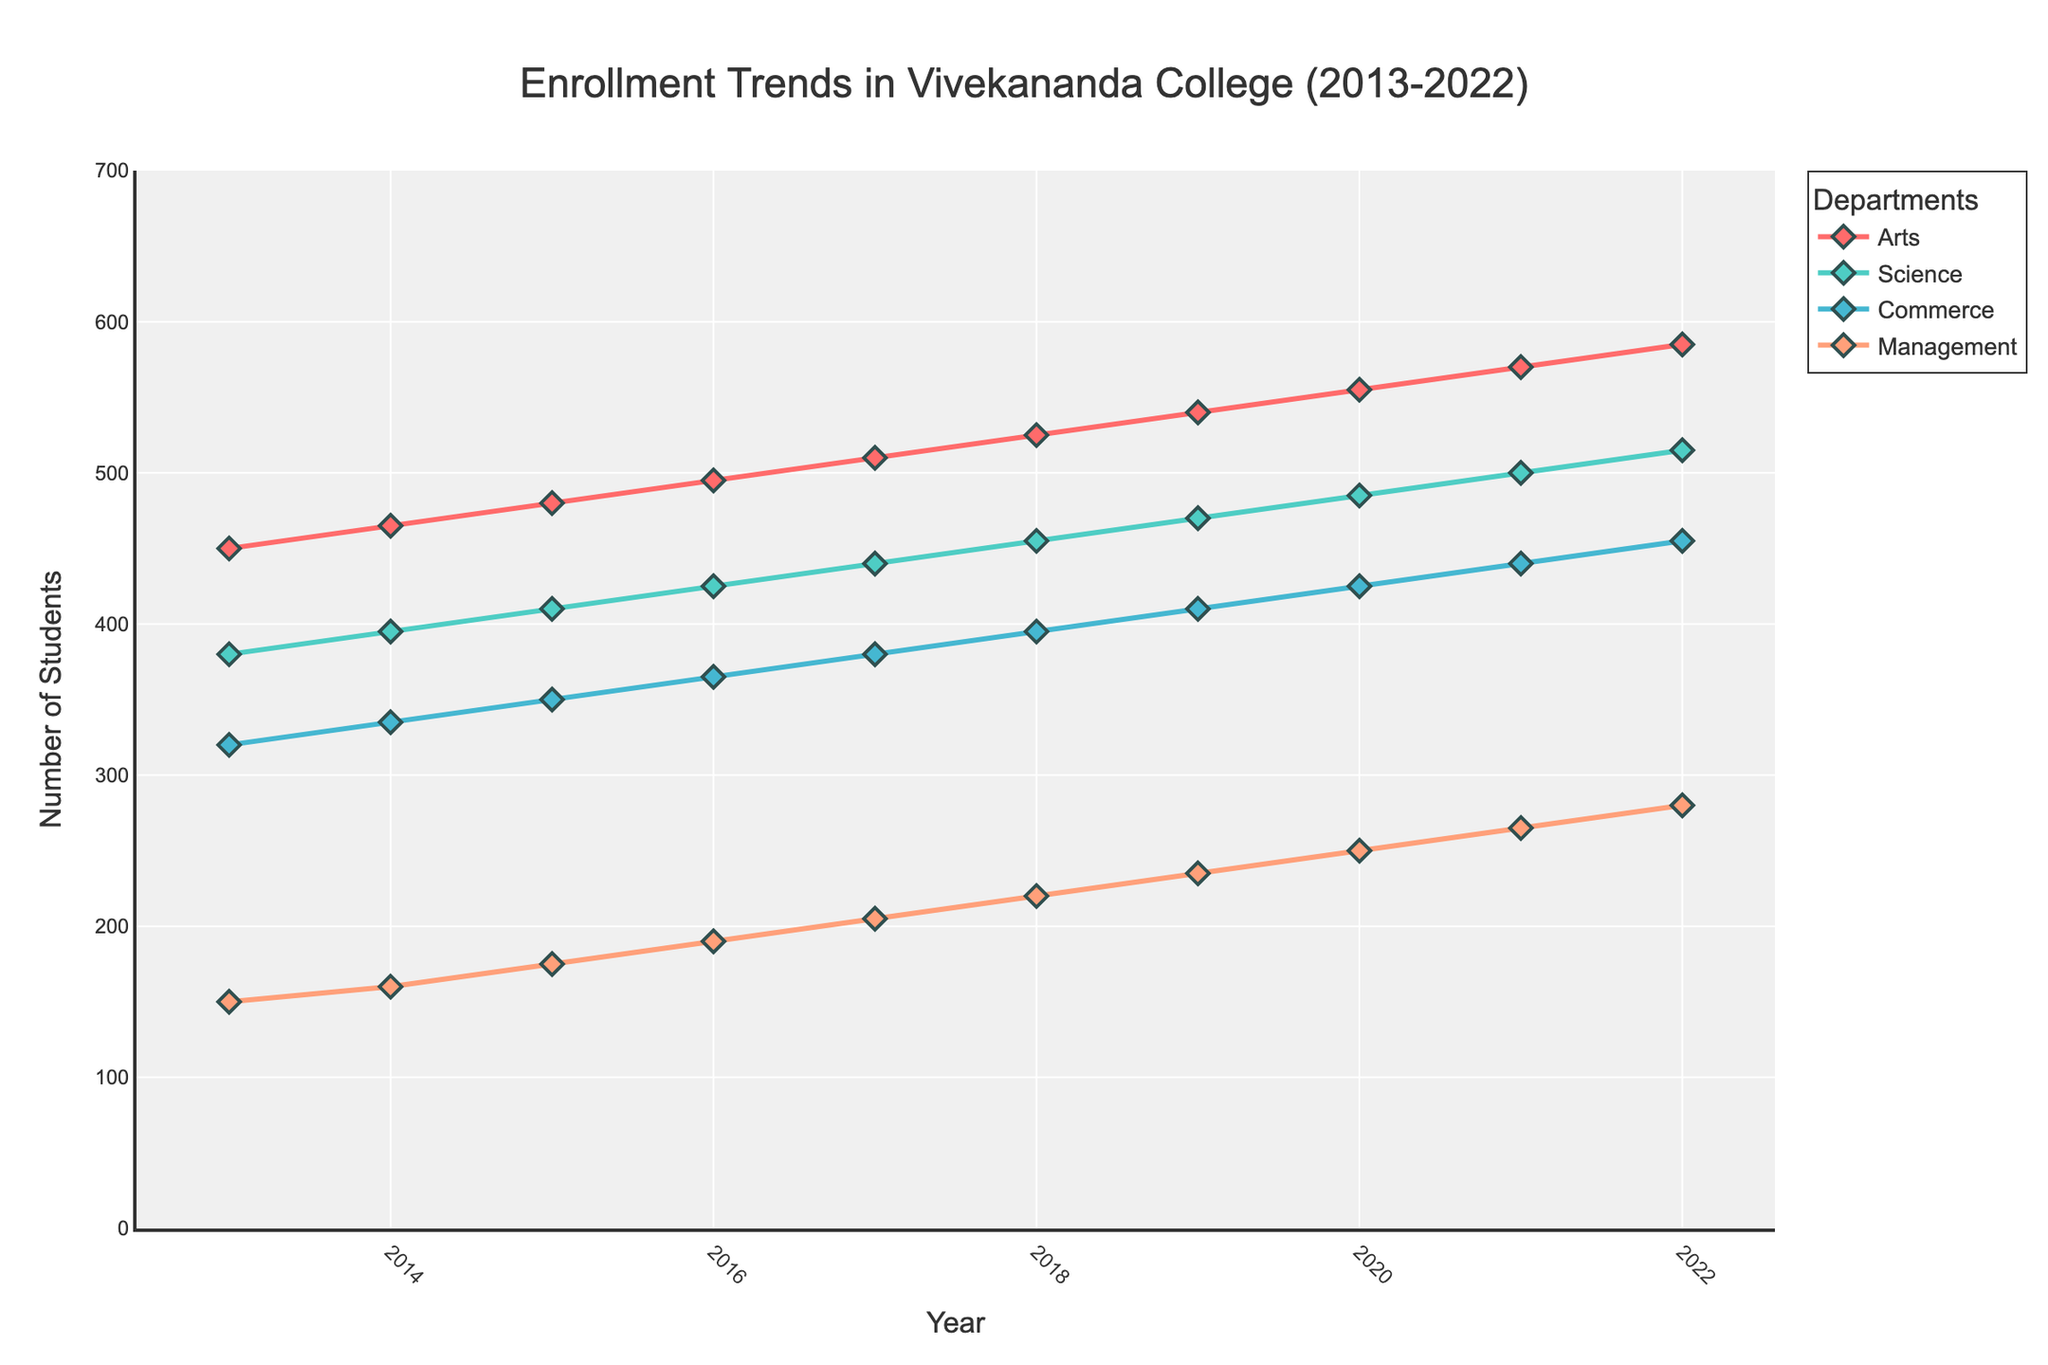Which department had the highest enrollment in 2022? The line representing the Arts department reaches the highest point in 2022 compared to other departments.
Answer: Arts Between 2015 and 2018, which department showed the greatest increase in enrollment? Calculate the enrollment difference between 2015 and 2018 for each department: 
- Arts: 525 - 480 = 45
- Science: 455 - 410 = 45
- Commerce: 395 - 350 = 45
- Management: 220 - 175 = 45
All departments showed the same increase.
Answer: All departments, 45 Which year did the Commerce department first exceed 400 students? Trace the line for the Commerce department and find the year when it first crossed above the 400-mark, which is 2019.
Answer: 2019 By how many students did the Science department increase from 2013 to 2022? Subtract the number of students in 2013 from that in 2022 for Science: 515 - 380 = 135.
Answer: 135 In which year did the Management department see an enrollment of exactly 175 students? Look at the Management line and find the year corresponding to the 175-student mark, which is 2015.
Answer: 2015 Compare the growth rate between 2016 and 2020 for the Arts and Science departments. Which one grew faster? Calculate the enrollment difference for both departments between 2016 and 2020:
- Arts: 555 - 495 = 60
- Science: 485 - 425 = 60
Both departments grew by the same number of students.
Answer: Both, 60 What is the average number of students enrolled in the Commerce department from 2013 to 2022? Sum the number of students in the Commerce department from 2013 to 2022 and divide by the number of years: (320+335+350+365+380+395+410+425+440+455) / 10 = 3845 / 10 = 384.5.
Answer: 384.5 Which department exhibited the most uniform growth trend over the years? Examine the smoothness of the lines for each department. All lines show a consistent yearly increase, but the Arts department has the most consistent linear growth when visually inspected.
Answer: Arts Was there any year when all departments saw an increase in enrollment compared to the previous year? Inspect the whole chart to see that in each year from 2013 to 2022, all departments showed a steady increase, hence every year saw an increase compared to the previous one.
Answer: All years 